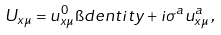<formula> <loc_0><loc_0><loc_500><loc_500>U _ { x \mu } = u ^ { 0 } _ { x \mu } \i d e n t i t y + i \sigma ^ { a } u ^ { a } _ { x \mu } \, ,</formula> 